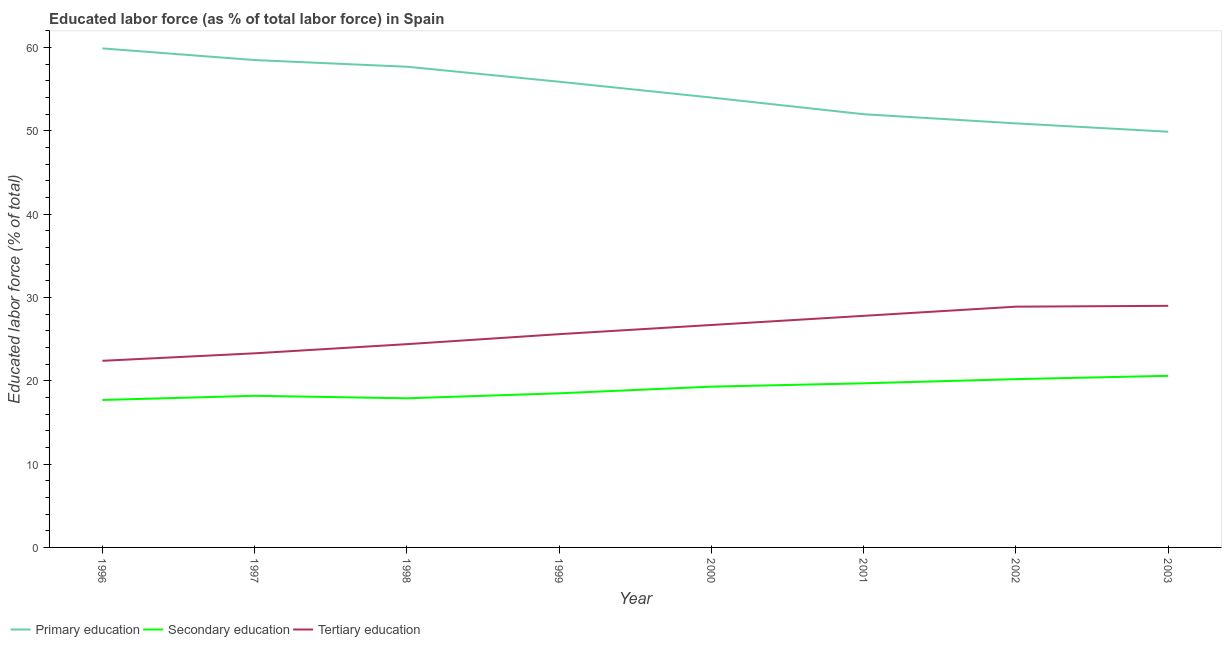Does the line corresponding to percentage of labor force who received tertiary education intersect with the line corresponding to percentage of labor force who received secondary education?
Ensure brevity in your answer.  No. What is the percentage of labor force who received tertiary education in 1999?
Give a very brief answer. 25.6. Across all years, what is the maximum percentage of labor force who received primary education?
Provide a short and direct response. 59.9. Across all years, what is the minimum percentage of labor force who received tertiary education?
Provide a short and direct response. 22.4. What is the total percentage of labor force who received primary education in the graph?
Make the answer very short. 438.8. What is the difference between the percentage of labor force who received tertiary education in 1999 and that in 2000?
Offer a very short reply. -1.1. What is the difference between the percentage of labor force who received secondary education in 1997 and the percentage of labor force who received tertiary education in 2001?
Provide a succinct answer. -9.6. What is the average percentage of labor force who received secondary education per year?
Ensure brevity in your answer.  19.01. In the year 1999, what is the difference between the percentage of labor force who received tertiary education and percentage of labor force who received secondary education?
Provide a short and direct response. 7.1. What is the ratio of the percentage of labor force who received primary education in 1998 to that in 2003?
Your answer should be very brief. 1.16. Is the percentage of labor force who received primary education in 2001 less than that in 2002?
Give a very brief answer. No. What is the difference between the highest and the second highest percentage of labor force who received tertiary education?
Give a very brief answer. 0.1. What is the difference between the highest and the lowest percentage of labor force who received secondary education?
Make the answer very short. 2.9. In how many years, is the percentage of labor force who received tertiary education greater than the average percentage of labor force who received tertiary education taken over all years?
Make the answer very short. 4. Does the percentage of labor force who received secondary education monotonically increase over the years?
Your answer should be very brief. No. How many lines are there?
Keep it short and to the point. 3. Does the graph contain any zero values?
Provide a short and direct response. No. How are the legend labels stacked?
Ensure brevity in your answer.  Horizontal. What is the title of the graph?
Offer a terse response. Educated labor force (as % of total labor force) in Spain. Does "Errors" appear as one of the legend labels in the graph?
Make the answer very short. No. What is the label or title of the X-axis?
Your answer should be very brief. Year. What is the label or title of the Y-axis?
Offer a terse response. Educated labor force (% of total). What is the Educated labor force (% of total) in Primary education in 1996?
Offer a terse response. 59.9. What is the Educated labor force (% of total) in Secondary education in 1996?
Your answer should be very brief. 17.7. What is the Educated labor force (% of total) in Tertiary education in 1996?
Your answer should be very brief. 22.4. What is the Educated labor force (% of total) in Primary education in 1997?
Give a very brief answer. 58.5. What is the Educated labor force (% of total) of Secondary education in 1997?
Offer a very short reply. 18.2. What is the Educated labor force (% of total) of Tertiary education in 1997?
Keep it short and to the point. 23.3. What is the Educated labor force (% of total) in Primary education in 1998?
Keep it short and to the point. 57.7. What is the Educated labor force (% of total) of Secondary education in 1998?
Offer a very short reply. 17.9. What is the Educated labor force (% of total) of Tertiary education in 1998?
Provide a short and direct response. 24.4. What is the Educated labor force (% of total) of Primary education in 1999?
Offer a terse response. 55.9. What is the Educated labor force (% of total) of Secondary education in 1999?
Provide a succinct answer. 18.5. What is the Educated labor force (% of total) of Tertiary education in 1999?
Give a very brief answer. 25.6. What is the Educated labor force (% of total) of Secondary education in 2000?
Offer a very short reply. 19.3. What is the Educated labor force (% of total) in Tertiary education in 2000?
Provide a succinct answer. 26.7. What is the Educated labor force (% of total) of Secondary education in 2001?
Provide a succinct answer. 19.7. What is the Educated labor force (% of total) of Tertiary education in 2001?
Your answer should be compact. 27.8. What is the Educated labor force (% of total) in Primary education in 2002?
Make the answer very short. 50.9. What is the Educated labor force (% of total) of Secondary education in 2002?
Ensure brevity in your answer.  20.2. What is the Educated labor force (% of total) in Tertiary education in 2002?
Your answer should be very brief. 28.9. What is the Educated labor force (% of total) in Primary education in 2003?
Offer a very short reply. 49.9. What is the Educated labor force (% of total) of Secondary education in 2003?
Provide a succinct answer. 20.6. What is the Educated labor force (% of total) of Tertiary education in 2003?
Offer a terse response. 29. Across all years, what is the maximum Educated labor force (% of total) in Primary education?
Offer a very short reply. 59.9. Across all years, what is the maximum Educated labor force (% of total) in Secondary education?
Your response must be concise. 20.6. Across all years, what is the maximum Educated labor force (% of total) of Tertiary education?
Make the answer very short. 29. Across all years, what is the minimum Educated labor force (% of total) in Primary education?
Keep it short and to the point. 49.9. Across all years, what is the minimum Educated labor force (% of total) in Secondary education?
Your response must be concise. 17.7. Across all years, what is the minimum Educated labor force (% of total) of Tertiary education?
Offer a very short reply. 22.4. What is the total Educated labor force (% of total) in Primary education in the graph?
Offer a very short reply. 438.8. What is the total Educated labor force (% of total) in Secondary education in the graph?
Provide a succinct answer. 152.1. What is the total Educated labor force (% of total) in Tertiary education in the graph?
Offer a terse response. 208.1. What is the difference between the Educated labor force (% of total) in Primary education in 1996 and that in 1997?
Make the answer very short. 1.4. What is the difference between the Educated labor force (% of total) of Primary education in 1996 and that in 1998?
Offer a very short reply. 2.2. What is the difference between the Educated labor force (% of total) in Secondary education in 1996 and that in 1998?
Make the answer very short. -0.2. What is the difference between the Educated labor force (% of total) of Tertiary education in 1996 and that in 1998?
Provide a short and direct response. -2. What is the difference between the Educated labor force (% of total) of Tertiary education in 1996 and that in 1999?
Ensure brevity in your answer.  -3.2. What is the difference between the Educated labor force (% of total) in Primary education in 1996 and that in 2000?
Your response must be concise. 5.9. What is the difference between the Educated labor force (% of total) of Primary education in 1996 and that in 2001?
Keep it short and to the point. 7.9. What is the difference between the Educated labor force (% of total) in Secondary education in 1996 and that in 2001?
Your response must be concise. -2. What is the difference between the Educated labor force (% of total) of Tertiary education in 1996 and that in 2001?
Give a very brief answer. -5.4. What is the difference between the Educated labor force (% of total) in Secondary education in 1996 and that in 2002?
Ensure brevity in your answer.  -2.5. What is the difference between the Educated labor force (% of total) of Primary education in 1996 and that in 2003?
Ensure brevity in your answer.  10. What is the difference between the Educated labor force (% of total) of Tertiary education in 1996 and that in 2003?
Your answer should be compact. -6.6. What is the difference between the Educated labor force (% of total) of Primary education in 1997 and that in 1999?
Make the answer very short. 2.6. What is the difference between the Educated labor force (% of total) of Secondary education in 1997 and that in 1999?
Provide a short and direct response. -0.3. What is the difference between the Educated labor force (% of total) of Secondary education in 1997 and that in 2000?
Your answer should be very brief. -1.1. What is the difference between the Educated labor force (% of total) of Tertiary education in 1997 and that in 2000?
Your answer should be very brief. -3.4. What is the difference between the Educated labor force (% of total) of Primary education in 1997 and that in 2001?
Give a very brief answer. 6.5. What is the difference between the Educated labor force (% of total) in Tertiary education in 1997 and that in 2001?
Keep it short and to the point. -4.5. What is the difference between the Educated labor force (% of total) of Primary education in 1997 and that in 2002?
Ensure brevity in your answer.  7.6. What is the difference between the Educated labor force (% of total) of Secondary education in 1997 and that in 2002?
Your answer should be very brief. -2. What is the difference between the Educated labor force (% of total) of Tertiary education in 1997 and that in 2002?
Give a very brief answer. -5.6. What is the difference between the Educated labor force (% of total) of Primary education in 1997 and that in 2003?
Give a very brief answer. 8.6. What is the difference between the Educated labor force (% of total) of Tertiary education in 1997 and that in 2003?
Your answer should be very brief. -5.7. What is the difference between the Educated labor force (% of total) of Secondary education in 1998 and that in 2001?
Keep it short and to the point. -1.8. What is the difference between the Educated labor force (% of total) of Tertiary education in 1998 and that in 2001?
Your answer should be very brief. -3.4. What is the difference between the Educated labor force (% of total) in Secondary education in 1998 and that in 2002?
Your answer should be very brief. -2.3. What is the difference between the Educated labor force (% of total) of Primary education in 1998 and that in 2003?
Ensure brevity in your answer.  7.8. What is the difference between the Educated labor force (% of total) in Tertiary education in 1998 and that in 2003?
Your response must be concise. -4.6. What is the difference between the Educated labor force (% of total) in Primary education in 1999 and that in 2000?
Give a very brief answer. 1.9. What is the difference between the Educated labor force (% of total) of Tertiary education in 1999 and that in 2000?
Make the answer very short. -1.1. What is the difference between the Educated labor force (% of total) in Tertiary education in 1999 and that in 2001?
Give a very brief answer. -2.2. What is the difference between the Educated labor force (% of total) of Secondary education in 1999 and that in 2002?
Your response must be concise. -1.7. What is the difference between the Educated labor force (% of total) in Tertiary education in 1999 and that in 2002?
Ensure brevity in your answer.  -3.3. What is the difference between the Educated labor force (% of total) of Primary education in 1999 and that in 2003?
Your answer should be very brief. 6. What is the difference between the Educated labor force (% of total) in Primary education in 2000 and that in 2001?
Your answer should be compact. 2. What is the difference between the Educated labor force (% of total) of Secondary education in 2000 and that in 2001?
Offer a very short reply. -0.4. What is the difference between the Educated labor force (% of total) of Primary education in 2000 and that in 2003?
Your answer should be very brief. 4.1. What is the difference between the Educated labor force (% of total) of Secondary education in 2000 and that in 2003?
Give a very brief answer. -1.3. What is the difference between the Educated labor force (% of total) of Tertiary education in 2000 and that in 2003?
Your answer should be compact. -2.3. What is the difference between the Educated labor force (% of total) of Primary education in 2001 and that in 2002?
Your response must be concise. 1.1. What is the difference between the Educated labor force (% of total) in Primary education in 2001 and that in 2003?
Ensure brevity in your answer.  2.1. What is the difference between the Educated labor force (% of total) in Tertiary education in 2001 and that in 2003?
Keep it short and to the point. -1.2. What is the difference between the Educated labor force (% of total) in Primary education in 1996 and the Educated labor force (% of total) in Secondary education in 1997?
Offer a very short reply. 41.7. What is the difference between the Educated labor force (% of total) of Primary education in 1996 and the Educated labor force (% of total) of Tertiary education in 1997?
Offer a terse response. 36.6. What is the difference between the Educated labor force (% of total) of Primary education in 1996 and the Educated labor force (% of total) of Tertiary education in 1998?
Your response must be concise. 35.5. What is the difference between the Educated labor force (% of total) in Secondary education in 1996 and the Educated labor force (% of total) in Tertiary education in 1998?
Make the answer very short. -6.7. What is the difference between the Educated labor force (% of total) of Primary education in 1996 and the Educated labor force (% of total) of Secondary education in 1999?
Your response must be concise. 41.4. What is the difference between the Educated labor force (% of total) in Primary education in 1996 and the Educated labor force (% of total) in Tertiary education in 1999?
Offer a very short reply. 34.3. What is the difference between the Educated labor force (% of total) of Primary education in 1996 and the Educated labor force (% of total) of Secondary education in 2000?
Provide a succinct answer. 40.6. What is the difference between the Educated labor force (% of total) of Primary education in 1996 and the Educated labor force (% of total) of Tertiary education in 2000?
Provide a short and direct response. 33.2. What is the difference between the Educated labor force (% of total) of Secondary education in 1996 and the Educated labor force (% of total) of Tertiary education in 2000?
Your answer should be very brief. -9. What is the difference between the Educated labor force (% of total) of Primary education in 1996 and the Educated labor force (% of total) of Secondary education in 2001?
Provide a succinct answer. 40.2. What is the difference between the Educated labor force (% of total) in Primary education in 1996 and the Educated labor force (% of total) in Tertiary education in 2001?
Your response must be concise. 32.1. What is the difference between the Educated labor force (% of total) in Primary education in 1996 and the Educated labor force (% of total) in Secondary education in 2002?
Give a very brief answer. 39.7. What is the difference between the Educated labor force (% of total) of Primary education in 1996 and the Educated labor force (% of total) of Tertiary education in 2002?
Offer a very short reply. 31. What is the difference between the Educated labor force (% of total) of Primary education in 1996 and the Educated labor force (% of total) of Secondary education in 2003?
Your answer should be compact. 39.3. What is the difference between the Educated labor force (% of total) of Primary education in 1996 and the Educated labor force (% of total) of Tertiary education in 2003?
Provide a succinct answer. 30.9. What is the difference between the Educated labor force (% of total) of Secondary education in 1996 and the Educated labor force (% of total) of Tertiary education in 2003?
Ensure brevity in your answer.  -11.3. What is the difference between the Educated labor force (% of total) of Primary education in 1997 and the Educated labor force (% of total) of Secondary education in 1998?
Ensure brevity in your answer.  40.6. What is the difference between the Educated labor force (% of total) in Primary education in 1997 and the Educated labor force (% of total) in Tertiary education in 1998?
Make the answer very short. 34.1. What is the difference between the Educated labor force (% of total) of Secondary education in 1997 and the Educated labor force (% of total) of Tertiary education in 1998?
Ensure brevity in your answer.  -6.2. What is the difference between the Educated labor force (% of total) of Primary education in 1997 and the Educated labor force (% of total) of Secondary education in 1999?
Give a very brief answer. 40. What is the difference between the Educated labor force (% of total) in Primary education in 1997 and the Educated labor force (% of total) in Tertiary education in 1999?
Your response must be concise. 32.9. What is the difference between the Educated labor force (% of total) of Primary education in 1997 and the Educated labor force (% of total) of Secondary education in 2000?
Provide a succinct answer. 39.2. What is the difference between the Educated labor force (% of total) in Primary education in 1997 and the Educated labor force (% of total) in Tertiary education in 2000?
Give a very brief answer. 31.8. What is the difference between the Educated labor force (% of total) in Secondary education in 1997 and the Educated labor force (% of total) in Tertiary education in 2000?
Offer a terse response. -8.5. What is the difference between the Educated labor force (% of total) in Primary education in 1997 and the Educated labor force (% of total) in Secondary education in 2001?
Provide a succinct answer. 38.8. What is the difference between the Educated labor force (% of total) in Primary education in 1997 and the Educated labor force (% of total) in Tertiary education in 2001?
Give a very brief answer. 30.7. What is the difference between the Educated labor force (% of total) of Primary education in 1997 and the Educated labor force (% of total) of Secondary education in 2002?
Make the answer very short. 38.3. What is the difference between the Educated labor force (% of total) in Primary education in 1997 and the Educated labor force (% of total) in Tertiary education in 2002?
Provide a short and direct response. 29.6. What is the difference between the Educated labor force (% of total) in Secondary education in 1997 and the Educated labor force (% of total) in Tertiary education in 2002?
Offer a very short reply. -10.7. What is the difference between the Educated labor force (% of total) in Primary education in 1997 and the Educated labor force (% of total) in Secondary education in 2003?
Your answer should be compact. 37.9. What is the difference between the Educated labor force (% of total) of Primary education in 1997 and the Educated labor force (% of total) of Tertiary education in 2003?
Keep it short and to the point. 29.5. What is the difference between the Educated labor force (% of total) of Primary education in 1998 and the Educated labor force (% of total) of Secondary education in 1999?
Your answer should be very brief. 39.2. What is the difference between the Educated labor force (% of total) in Primary education in 1998 and the Educated labor force (% of total) in Tertiary education in 1999?
Offer a terse response. 32.1. What is the difference between the Educated labor force (% of total) of Primary education in 1998 and the Educated labor force (% of total) of Secondary education in 2000?
Give a very brief answer. 38.4. What is the difference between the Educated labor force (% of total) in Primary education in 1998 and the Educated labor force (% of total) in Tertiary education in 2000?
Offer a very short reply. 31. What is the difference between the Educated labor force (% of total) in Primary education in 1998 and the Educated labor force (% of total) in Secondary education in 2001?
Provide a short and direct response. 38. What is the difference between the Educated labor force (% of total) in Primary education in 1998 and the Educated labor force (% of total) in Tertiary education in 2001?
Provide a succinct answer. 29.9. What is the difference between the Educated labor force (% of total) in Primary education in 1998 and the Educated labor force (% of total) in Secondary education in 2002?
Ensure brevity in your answer.  37.5. What is the difference between the Educated labor force (% of total) of Primary education in 1998 and the Educated labor force (% of total) of Tertiary education in 2002?
Provide a succinct answer. 28.8. What is the difference between the Educated labor force (% of total) in Primary education in 1998 and the Educated labor force (% of total) in Secondary education in 2003?
Keep it short and to the point. 37.1. What is the difference between the Educated labor force (% of total) in Primary education in 1998 and the Educated labor force (% of total) in Tertiary education in 2003?
Ensure brevity in your answer.  28.7. What is the difference between the Educated labor force (% of total) of Secondary education in 1998 and the Educated labor force (% of total) of Tertiary education in 2003?
Provide a succinct answer. -11.1. What is the difference between the Educated labor force (% of total) in Primary education in 1999 and the Educated labor force (% of total) in Secondary education in 2000?
Provide a short and direct response. 36.6. What is the difference between the Educated labor force (% of total) in Primary education in 1999 and the Educated labor force (% of total) in Tertiary education in 2000?
Your response must be concise. 29.2. What is the difference between the Educated labor force (% of total) of Secondary education in 1999 and the Educated labor force (% of total) of Tertiary education in 2000?
Your answer should be very brief. -8.2. What is the difference between the Educated labor force (% of total) of Primary education in 1999 and the Educated labor force (% of total) of Secondary education in 2001?
Provide a short and direct response. 36.2. What is the difference between the Educated labor force (% of total) in Primary education in 1999 and the Educated labor force (% of total) in Tertiary education in 2001?
Offer a terse response. 28.1. What is the difference between the Educated labor force (% of total) of Secondary education in 1999 and the Educated labor force (% of total) of Tertiary education in 2001?
Your answer should be very brief. -9.3. What is the difference between the Educated labor force (% of total) of Primary education in 1999 and the Educated labor force (% of total) of Secondary education in 2002?
Ensure brevity in your answer.  35.7. What is the difference between the Educated labor force (% of total) in Secondary education in 1999 and the Educated labor force (% of total) in Tertiary education in 2002?
Provide a short and direct response. -10.4. What is the difference between the Educated labor force (% of total) of Primary education in 1999 and the Educated labor force (% of total) of Secondary education in 2003?
Provide a succinct answer. 35.3. What is the difference between the Educated labor force (% of total) of Primary education in 1999 and the Educated labor force (% of total) of Tertiary education in 2003?
Provide a short and direct response. 26.9. What is the difference between the Educated labor force (% of total) in Primary education in 2000 and the Educated labor force (% of total) in Secondary education in 2001?
Offer a very short reply. 34.3. What is the difference between the Educated labor force (% of total) in Primary education in 2000 and the Educated labor force (% of total) in Tertiary education in 2001?
Ensure brevity in your answer.  26.2. What is the difference between the Educated labor force (% of total) of Primary education in 2000 and the Educated labor force (% of total) of Secondary education in 2002?
Your answer should be very brief. 33.8. What is the difference between the Educated labor force (% of total) in Primary education in 2000 and the Educated labor force (% of total) in Tertiary education in 2002?
Ensure brevity in your answer.  25.1. What is the difference between the Educated labor force (% of total) of Primary education in 2000 and the Educated labor force (% of total) of Secondary education in 2003?
Offer a terse response. 33.4. What is the difference between the Educated labor force (% of total) of Primary education in 2001 and the Educated labor force (% of total) of Secondary education in 2002?
Your answer should be very brief. 31.8. What is the difference between the Educated labor force (% of total) of Primary education in 2001 and the Educated labor force (% of total) of Tertiary education in 2002?
Give a very brief answer. 23.1. What is the difference between the Educated labor force (% of total) of Secondary education in 2001 and the Educated labor force (% of total) of Tertiary education in 2002?
Provide a succinct answer. -9.2. What is the difference between the Educated labor force (% of total) of Primary education in 2001 and the Educated labor force (% of total) of Secondary education in 2003?
Keep it short and to the point. 31.4. What is the difference between the Educated labor force (% of total) in Primary education in 2001 and the Educated labor force (% of total) in Tertiary education in 2003?
Your answer should be very brief. 23. What is the difference between the Educated labor force (% of total) in Primary education in 2002 and the Educated labor force (% of total) in Secondary education in 2003?
Provide a succinct answer. 30.3. What is the difference between the Educated labor force (% of total) of Primary education in 2002 and the Educated labor force (% of total) of Tertiary education in 2003?
Offer a terse response. 21.9. What is the average Educated labor force (% of total) in Primary education per year?
Keep it short and to the point. 54.85. What is the average Educated labor force (% of total) of Secondary education per year?
Ensure brevity in your answer.  19.01. What is the average Educated labor force (% of total) of Tertiary education per year?
Provide a succinct answer. 26.01. In the year 1996, what is the difference between the Educated labor force (% of total) of Primary education and Educated labor force (% of total) of Secondary education?
Keep it short and to the point. 42.2. In the year 1996, what is the difference between the Educated labor force (% of total) of Primary education and Educated labor force (% of total) of Tertiary education?
Offer a very short reply. 37.5. In the year 1997, what is the difference between the Educated labor force (% of total) of Primary education and Educated labor force (% of total) of Secondary education?
Your response must be concise. 40.3. In the year 1997, what is the difference between the Educated labor force (% of total) of Primary education and Educated labor force (% of total) of Tertiary education?
Give a very brief answer. 35.2. In the year 1998, what is the difference between the Educated labor force (% of total) of Primary education and Educated labor force (% of total) of Secondary education?
Your answer should be very brief. 39.8. In the year 1998, what is the difference between the Educated labor force (% of total) in Primary education and Educated labor force (% of total) in Tertiary education?
Your answer should be very brief. 33.3. In the year 1998, what is the difference between the Educated labor force (% of total) of Secondary education and Educated labor force (% of total) of Tertiary education?
Provide a short and direct response. -6.5. In the year 1999, what is the difference between the Educated labor force (% of total) in Primary education and Educated labor force (% of total) in Secondary education?
Offer a terse response. 37.4. In the year 1999, what is the difference between the Educated labor force (% of total) in Primary education and Educated labor force (% of total) in Tertiary education?
Make the answer very short. 30.3. In the year 2000, what is the difference between the Educated labor force (% of total) of Primary education and Educated labor force (% of total) of Secondary education?
Ensure brevity in your answer.  34.7. In the year 2000, what is the difference between the Educated labor force (% of total) of Primary education and Educated labor force (% of total) of Tertiary education?
Offer a very short reply. 27.3. In the year 2000, what is the difference between the Educated labor force (% of total) in Secondary education and Educated labor force (% of total) in Tertiary education?
Give a very brief answer. -7.4. In the year 2001, what is the difference between the Educated labor force (% of total) of Primary education and Educated labor force (% of total) of Secondary education?
Offer a very short reply. 32.3. In the year 2001, what is the difference between the Educated labor force (% of total) in Primary education and Educated labor force (% of total) in Tertiary education?
Offer a very short reply. 24.2. In the year 2002, what is the difference between the Educated labor force (% of total) of Primary education and Educated labor force (% of total) of Secondary education?
Offer a terse response. 30.7. In the year 2003, what is the difference between the Educated labor force (% of total) in Primary education and Educated labor force (% of total) in Secondary education?
Give a very brief answer. 29.3. In the year 2003, what is the difference between the Educated labor force (% of total) in Primary education and Educated labor force (% of total) in Tertiary education?
Keep it short and to the point. 20.9. What is the ratio of the Educated labor force (% of total) in Primary education in 1996 to that in 1997?
Your answer should be very brief. 1.02. What is the ratio of the Educated labor force (% of total) of Secondary education in 1996 to that in 1997?
Your answer should be very brief. 0.97. What is the ratio of the Educated labor force (% of total) in Tertiary education in 1996 to that in 1997?
Give a very brief answer. 0.96. What is the ratio of the Educated labor force (% of total) in Primary education in 1996 to that in 1998?
Provide a short and direct response. 1.04. What is the ratio of the Educated labor force (% of total) of Tertiary education in 1996 to that in 1998?
Give a very brief answer. 0.92. What is the ratio of the Educated labor force (% of total) in Primary education in 1996 to that in 1999?
Your response must be concise. 1.07. What is the ratio of the Educated labor force (% of total) in Secondary education in 1996 to that in 1999?
Make the answer very short. 0.96. What is the ratio of the Educated labor force (% of total) in Tertiary education in 1996 to that in 1999?
Ensure brevity in your answer.  0.88. What is the ratio of the Educated labor force (% of total) in Primary education in 1996 to that in 2000?
Keep it short and to the point. 1.11. What is the ratio of the Educated labor force (% of total) of Secondary education in 1996 to that in 2000?
Your response must be concise. 0.92. What is the ratio of the Educated labor force (% of total) of Tertiary education in 1996 to that in 2000?
Offer a terse response. 0.84. What is the ratio of the Educated labor force (% of total) of Primary education in 1996 to that in 2001?
Make the answer very short. 1.15. What is the ratio of the Educated labor force (% of total) in Secondary education in 1996 to that in 2001?
Keep it short and to the point. 0.9. What is the ratio of the Educated labor force (% of total) of Tertiary education in 1996 to that in 2001?
Give a very brief answer. 0.81. What is the ratio of the Educated labor force (% of total) in Primary education in 1996 to that in 2002?
Provide a short and direct response. 1.18. What is the ratio of the Educated labor force (% of total) in Secondary education in 1996 to that in 2002?
Offer a terse response. 0.88. What is the ratio of the Educated labor force (% of total) in Tertiary education in 1996 to that in 2002?
Give a very brief answer. 0.78. What is the ratio of the Educated labor force (% of total) in Primary education in 1996 to that in 2003?
Give a very brief answer. 1.2. What is the ratio of the Educated labor force (% of total) in Secondary education in 1996 to that in 2003?
Your response must be concise. 0.86. What is the ratio of the Educated labor force (% of total) of Tertiary education in 1996 to that in 2003?
Provide a succinct answer. 0.77. What is the ratio of the Educated labor force (% of total) in Primary education in 1997 to that in 1998?
Provide a short and direct response. 1.01. What is the ratio of the Educated labor force (% of total) of Secondary education in 1997 to that in 1998?
Keep it short and to the point. 1.02. What is the ratio of the Educated labor force (% of total) in Tertiary education in 1997 to that in 1998?
Provide a short and direct response. 0.95. What is the ratio of the Educated labor force (% of total) of Primary education in 1997 to that in 1999?
Offer a terse response. 1.05. What is the ratio of the Educated labor force (% of total) in Secondary education in 1997 to that in 1999?
Provide a succinct answer. 0.98. What is the ratio of the Educated labor force (% of total) in Tertiary education in 1997 to that in 1999?
Your answer should be compact. 0.91. What is the ratio of the Educated labor force (% of total) in Primary education in 1997 to that in 2000?
Keep it short and to the point. 1.08. What is the ratio of the Educated labor force (% of total) of Secondary education in 1997 to that in 2000?
Give a very brief answer. 0.94. What is the ratio of the Educated labor force (% of total) in Tertiary education in 1997 to that in 2000?
Provide a succinct answer. 0.87. What is the ratio of the Educated labor force (% of total) of Primary education in 1997 to that in 2001?
Your answer should be compact. 1.12. What is the ratio of the Educated labor force (% of total) of Secondary education in 1997 to that in 2001?
Give a very brief answer. 0.92. What is the ratio of the Educated labor force (% of total) of Tertiary education in 1997 to that in 2001?
Provide a succinct answer. 0.84. What is the ratio of the Educated labor force (% of total) in Primary education in 1997 to that in 2002?
Make the answer very short. 1.15. What is the ratio of the Educated labor force (% of total) of Secondary education in 1997 to that in 2002?
Offer a very short reply. 0.9. What is the ratio of the Educated labor force (% of total) in Tertiary education in 1997 to that in 2002?
Your answer should be compact. 0.81. What is the ratio of the Educated labor force (% of total) in Primary education in 1997 to that in 2003?
Your answer should be very brief. 1.17. What is the ratio of the Educated labor force (% of total) in Secondary education in 1997 to that in 2003?
Provide a short and direct response. 0.88. What is the ratio of the Educated labor force (% of total) in Tertiary education in 1997 to that in 2003?
Your response must be concise. 0.8. What is the ratio of the Educated labor force (% of total) in Primary education in 1998 to that in 1999?
Provide a succinct answer. 1.03. What is the ratio of the Educated labor force (% of total) in Secondary education in 1998 to that in 1999?
Offer a terse response. 0.97. What is the ratio of the Educated labor force (% of total) of Tertiary education in 1998 to that in 1999?
Your answer should be compact. 0.95. What is the ratio of the Educated labor force (% of total) of Primary education in 1998 to that in 2000?
Offer a very short reply. 1.07. What is the ratio of the Educated labor force (% of total) of Secondary education in 1998 to that in 2000?
Offer a very short reply. 0.93. What is the ratio of the Educated labor force (% of total) of Tertiary education in 1998 to that in 2000?
Your response must be concise. 0.91. What is the ratio of the Educated labor force (% of total) in Primary education in 1998 to that in 2001?
Provide a short and direct response. 1.11. What is the ratio of the Educated labor force (% of total) in Secondary education in 1998 to that in 2001?
Your response must be concise. 0.91. What is the ratio of the Educated labor force (% of total) in Tertiary education in 1998 to that in 2001?
Ensure brevity in your answer.  0.88. What is the ratio of the Educated labor force (% of total) of Primary education in 1998 to that in 2002?
Keep it short and to the point. 1.13. What is the ratio of the Educated labor force (% of total) of Secondary education in 1998 to that in 2002?
Ensure brevity in your answer.  0.89. What is the ratio of the Educated labor force (% of total) in Tertiary education in 1998 to that in 2002?
Offer a terse response. 0.84. What is the ratio of the Educated labor force (% of total) in Primary education in 1998 to that in 2003?
Make the answer very short. 1.16. What is the ratio of the Educated labor force (% of total) in Secondary education in 1998 to that in 2003?
Your response must be concise. 0.87. What is the ratio of the Educated labor force (% of total) in Tertiary education in 1998 to that in 2003?
Provide a succinct answer. 0.84. What is the ratio of the Educated labor force (% of total) of Primary education in 1999 to that in 2000?
Make the answer very short. 1.04. What is the ratio of the Educated labor force (% of total) of Secondary education in 1999 to that in 2000?
Provide a succinct answer. 0.96. What is the ratio of the Educated labor force (% of total) of Tertiary education in 1999 to that in 2000?
Make the answer very short. 0.96. What is the ratio of the Educated labor force (% of total) of Primary education in 1999 to that in 2001?
Your response must be concise. 1.07. What is the ratio of the Educated labor force (% of total) of Secondary education in 1999 to that in 2001?
Offer a terse response. 0.94. What is the ratio of the Educated labor force (% of total) of Tertiary education in 1999 to that in 2001?
Offer a very short reply. 0.92. What is the ratio of the Educated labor force (% of total) in Primary education in 1999 to that in 2002?
Provide a succinct answer. 1.1. What is the ratio of the Educated labor force (% of total) in Secondary education in 1999 to that in 2002?
Ensure brevity in your answer.  0.92. What is the ratio of the Educated labor force (% of total) in Tertiary education in 1999 to that in 2002?
Ensure brevity in your answer.  0.89. What is the ratio of the Educated labor force (% of total) in Primary education in 1999 to that in 2003?
Your answer should be very brief. 1.12. What is the ratio of the Educated labor force (% of total) of Secondary education in 1999 to that in 2003?
Give a very brief answer. 0.9. What is the ratio of the Educated labor force (% of total) in Tertiary education in 1999 to that in 2003?
Make the answer very short. 0.88. What is the ratio of the Educated labor force (% of total) in Primary education in 2000 to that in 2001?
Keep it short and to the point. 1.04. What is the ratio of the Educated labor force (% of total) in Secondary education in 2000 to that in 2001?
Offer a very short reply. 0.98. What is the ratio of the Educated labor force (% of total) in Tertiary education in 2000 to that in 2001?
Your answer should be compact. 0.96. What is the ratio of the Educated labor force (% of total) in Primary education in 2000 to that in 2002?
Give a very brief answer. 1.06. What is the ratio of the Educated labor force (% of total) of Secondary education in 2000 to that in 2002?
Provide a succinct answer. 0.96. What is the ratio of the Educated labor force (% of total) in Tertiary education in 2000 to that in 2002?
Ensure brevity in your answer.  0.92. What is the ratio of the Educated labor force (% of total) of Primary education in 2000 to that in 2003?
Make the answer very short. 1.08. What is the ratio of the Educated labor force (% of total) in Secondary education in 2000 to that in 2003?
Give a very brief answer. 0.94. What is the ratio of the Educated labor force (% of total) of Tertiary education in 2000 to that in 2003?
Give a very brief answer. 0.92. What is the ratio of the Educated labor force (% of total) of Primary education in 2001 to that in 2002?
Provide a short and direct response. 1.02. What is the ratio of the Educated labor force (% of total) of Secondary education in 2001 to that in 2002?
Give a very brief answer. 0.98. What is the ratio of the Educated labor force (% of total) of Tertiary education in 2001 to that in 2002?
Make the answer very short. 0.96. What is the ratio of the Educated labor force (% of total) in Primary education in 2001 to that in 2003?
Offer a very short reply. 1.04. What is the ratio of the Educated labor force (% of total) in Secondary education in 2001 to that in 2003?
Offer a terse response. 0.96. What is the ratio of the Educated labor force (% of total) of Tertiary education in 2001 to that in 2003?
Your answer should be compact. 0.96. What is the ratio of the Educated labor force (% of total) of Primary education in 2002 to that in 2003?
Provide a succinct answer. 1.02. What is the ratio of the Educated labor force (% of total) of Secondary education in 2002 to that in 2003?
Give a very brief answer. 0.98. What is the ratio of the Educated labor force (% of total) of Tertiary education in 2002 to that in 2003?
Make the answer very short. 1. What is the difference between the highest and the second highest Educated labor force (% of total) in Secondary education?
Offer a very short reply. 0.4. What is the difference between the highest and the second highest Educated labor force (% of total) in Tertiary education?
Provide a succinct answer. 0.1. What is the difference between the highest and the lowest Educated labor force (% of total) of Primary education?
Your response must be concise. 10. What is the difference between the highest and the lowest Educated labor force (% of total) in Secondary education?
Your response must be concise. 2.9. 